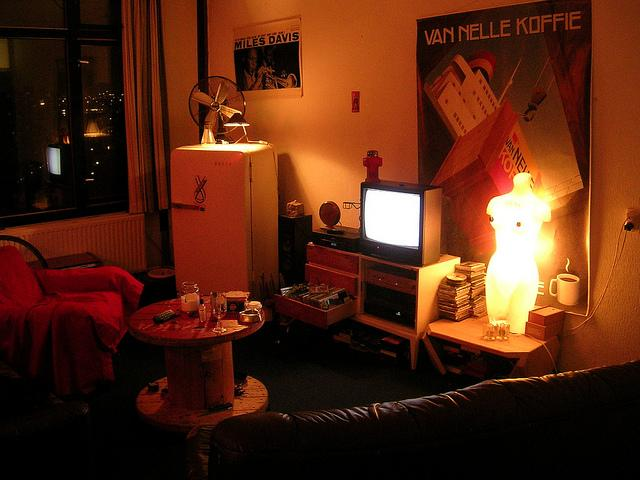The last word on the poster on the right is most likely pronounced similarly to what?

Choices:
A) coffee
B) juice
C) seltzer
D) soda coffee 